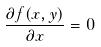<formula> <loc_0><loc_0><loc_500><loc_500>\frac { \partial f ( x , y ) } { \partial x } = 0</formula> 